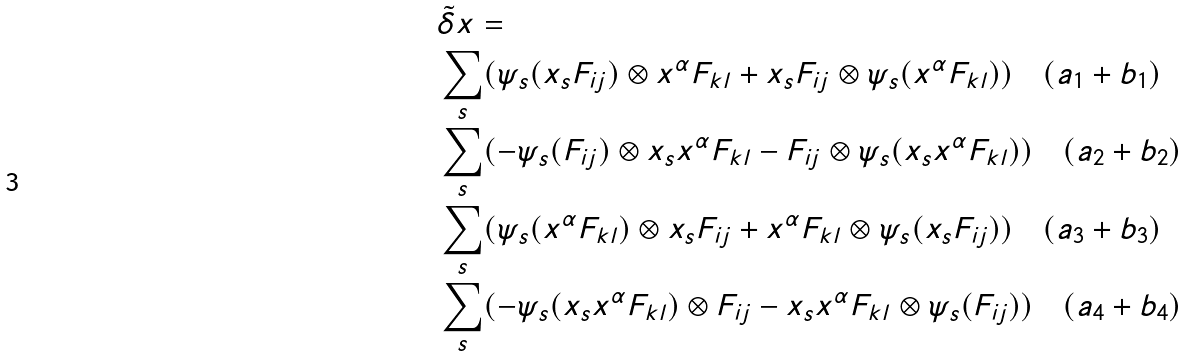Convert formula to latex. <formula><loc_0><loc_0><loc_500><loc_500>& \tilde { \delta } x = \\ & \sum _ { s } ( \psi _ { s } ( x _ { s } F _ { i j } ) \otimes x ^ { \alpha } F _ { k l } + x _ { s } F _ { i j } \otimes \psi _ { s } ( x ^ { \alpha } F _ { k l } ) ) \quad ( a _ { 1 } + b _ { 1 } ) \\ & \sum _ { s } ( - \psi _ { s } ( F _ { i j } ) \otimes x _ { s } x ^ { \alpha } F _ { k l } - F _ { i j } \otimes \psi _ { s } ( x _ { s } x ^ { \alpha } F _ { k l } ) ) \quad ( a _ { 2 } + b _ { 2 } ) \\ & \sum _ { s } ( \psi _ { s } ( x ^ { \alpha } F _ { k l } ) \otimes x _ { s } F _ { i j } + x ^ { \alpha } F _ { k l } \otimes \psi _ { s } ( x _ { s } F _ { i j } ) ) \quad ( a _ { 3 } + b _ { 3 } ) \\ & \sum _ { s } ( - \psi _ { s } ( x _ { s } x ^ { \alpha } F _ { k l } ) \otimes F _ { i j } - x _ { s } x ^ { \alpha } F _ { k l } \otimes \psi _ { s } ( F _ { i j } ) ) \quad ( a _ { 4 } + b _ { 4 } )</formula> 